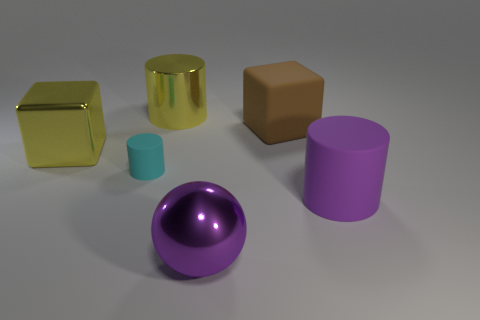Add 2 large red metallic cylinders. How many objects exist? 8 Subtract all blocks. How many objects are left? 4 Add 3 large metallic objects. How many large metallic objects are left? 6 Add 1 large purple objects. How many large purple objects exist? 3 Subtract 1 yellow cylinders. How many objects are left? 5 Subtract all big purple metal things. Subtract all small cylinders. How many objects are left? 4 